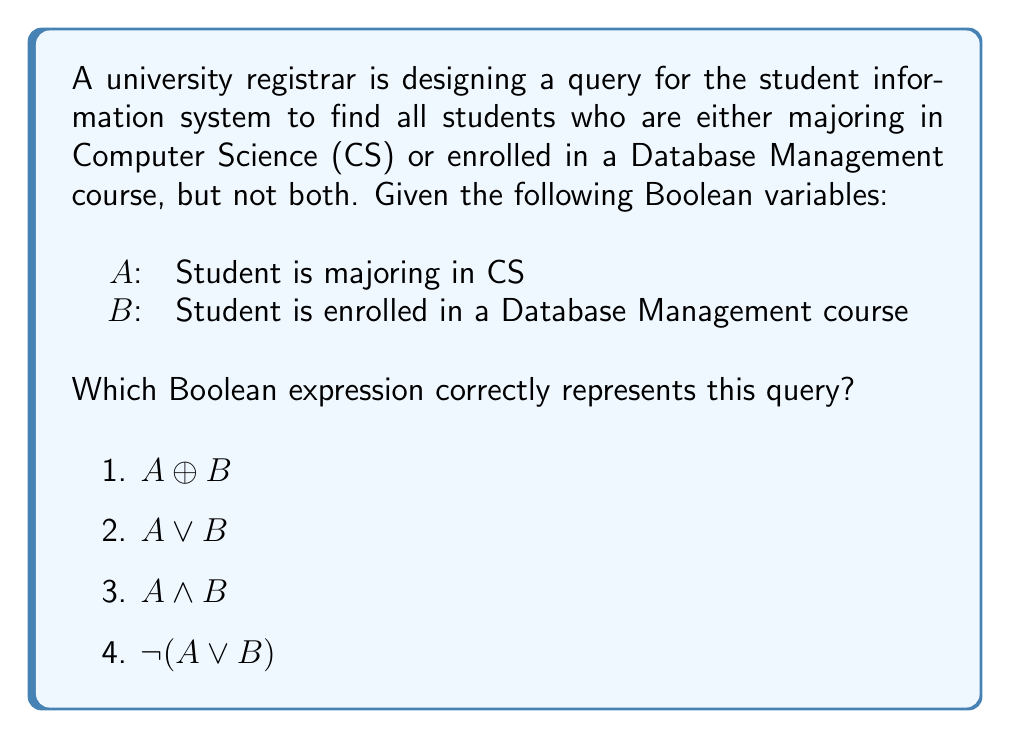Could you help me with this problem? Let's approach this step-by-step:

1) We need students who are either majoring in CS or enrolled in a Database Management course, but not both. This is the definition of an exclusive OR (XOR) operation.

2) The XOR operation, denoted by $\oplus$, returns true when exactly one of its inputs is true, but not both.

3) Let's examine the truth table for $A \oplus B$:

   $$
   \begin{array}{|c|c|c|}
   \hline
   A & B & A \oplus B \\
   \hline
   0 & 0 & 0 \\
   0 & 1 & 1 \\
   1 & 0 & 1 \\
   1 & 1 & 0 \\
   \hline
   \end{array}
   $$

4) This truth table matches our requirements:
   - It's true (1) when the student is in CS but not in Database Management.
   - It's true (1) when the student is in Database Management but not in CS.
   - It's false (0) when the student is in both or in neither.

5) Therefore, the correct Boolean expression for this query is $A \oplus B$.

6) The other options do not satisfy our requirements:
   - $A \lor B$ would include students in both CS and Database Management.
   - $A \land B$ would only include students in both CS and Database Management.
   - $\lnot(A \lor B)$ would only include students in neither CS nor Database Management.
Answer: $A \oplus B$ 